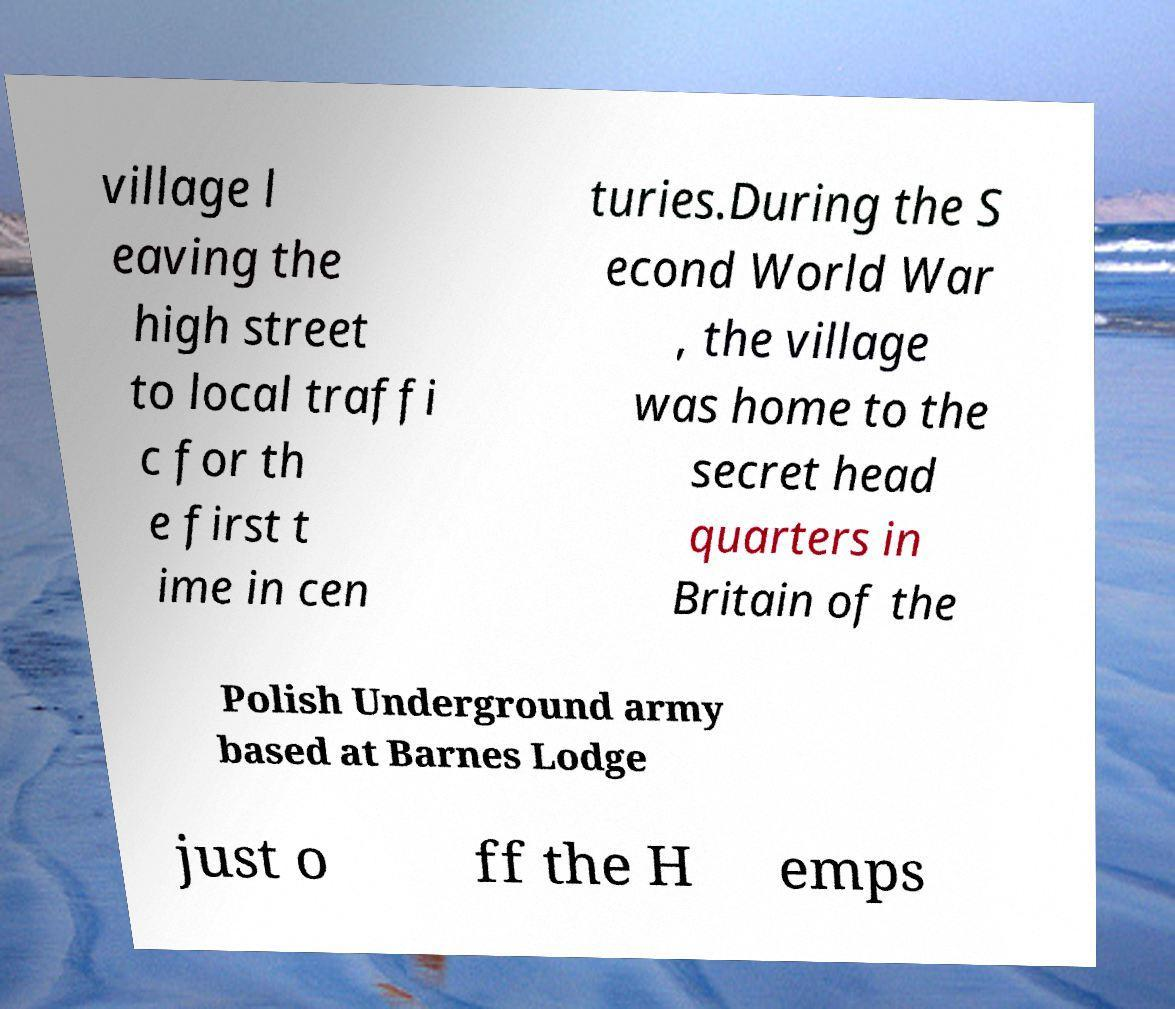Can you accurately transcribe the text from the provided image for me? village l eaving the high street to local traffi c for th e first t ime in cen turies.During the S econd World War , the village was home to the secret head quarters in Britain of the Polish Underground army based at Barnes Lodge just o ff the H emps 